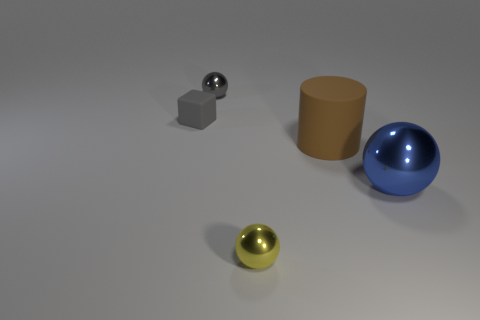There is a gray thing that is the same shape as the big blue metal thing; what is it made of?
Provide a short and direct response. Metal. What is the object that is both to the right of the yellow ball and behind the large blue metal object made of?
Your answer should be very brief. Rubber. Is the number of tiny things that are in front of the gray rubber block less than the number of big blue metallic balls that are in front of the big ball?
Ensure brevity in your answer.  No. What number of other objects are there of the same size as the brown rubber thing?
Your response must be concise. 1. What shape is the small metal object that is behind the tiny ball to the right of the object behind the matte cube?
Provide a short and direct response. Sphere. How many purple objects are either large cylinders or small balls?
Offer a very short reply. 0. There is a rubber thing behind the large brown rubber thing; what number of blocks are in front of it?
Provide a succinct answer. 0. Is there any other thing of the same color as the big matte cylinder?
Your response must be concise. No. What is the shape of the yellow thing that is made of the same material as the big ball?
Ensure brevity in your answer.  Sphere. Is the color of the small matte object the same as the cylinder?
Make the answer very short. No. 